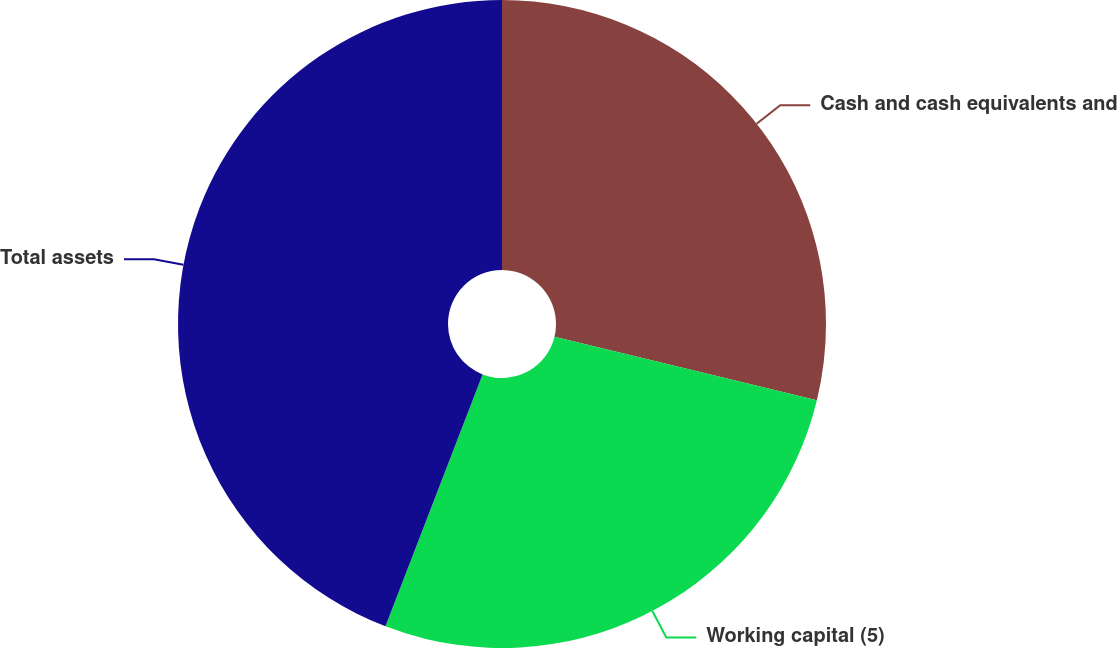<chart> <loc_0><loc_0><loc_500><loc_500><pie_chart><fcel>Cash and cash equivalents and<fcel>Working capital (5)<fcel>Total assets<nl><fcel>28.78%<fcel>27.07%<fcel>44.14%<nl></chart> 